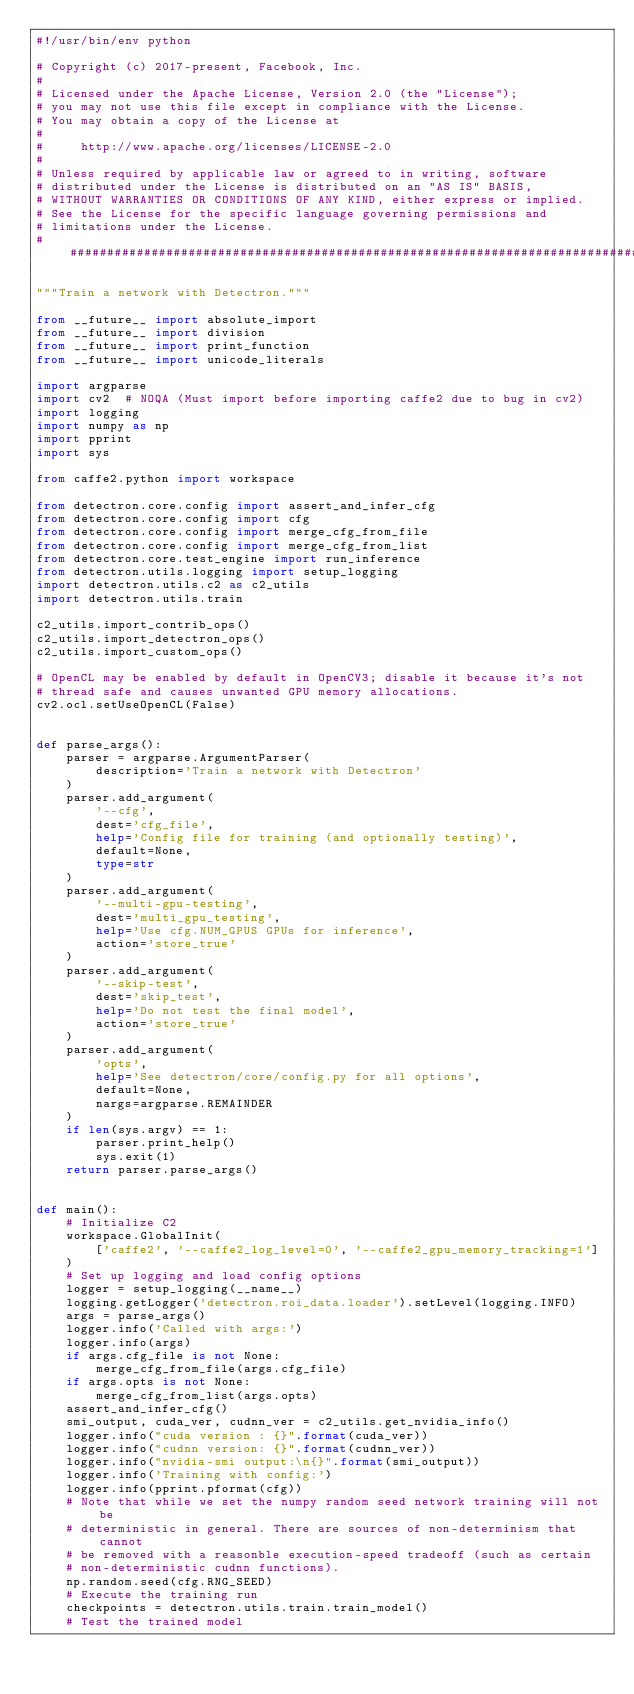Convert code to text. <code><loc_0><loc_0><loc_500><loc_500><_Python_>#!/usr/bin/env python

# Copyright (c) 2017-present, Facebook, Inc.
#
# Licensed under the Apache License, Version 2.0 (the "License");
# you may not use this file except in compliance with the License.
# You may obtain a copy of the License at
#
#     http://www.apache.org/licenses/LICENSE-2.0
#
# Unless required by applicable law or agreed to in writing, software
# distributed under the License is distributed on an "AS IS" BASIS,
# WITHOUT WARRANTIES OR CONDITIONS OF ANY KIND, either express or implied.
# See the License for the specific language governing permissions and
# limitations under the License.
##############################################################################

"""Train a network with Detectron."""

from __future__ import absolute_import
from __future__ import division
from __future__ import print_function
from __future__ import unicode_literals

import argparse
import cv2  # NOQA (Must import before importing caffe2 due to bug in cv2)
import logging
import numpy as np
import pprint
import sys

from caffe2.python import workspace

from detectron.core.config import assert_and_infer_cfg
from detectron.core.config import cfg
from detectron.core.config import merge_cfg_from_file
from detectron.core.config import merge_cfg_from_list
from detectron.core.test_engine import run_inference
from detectron.utils.logging import setup_logging
import detectron.utils.c2 as c2_utils
import detectron.utils.train

c2_utils.import_contrib_ops()
c2_utils.import_detectron_ops()
c2_utils.import_custom_ops()

# OpenCL may be enabled by default in OpenCV3; disable it because it's not
# thread safe and causes unwanted GPU memory allocations.
cv2.ocl.setUseOpenCL(False)


def parse_args():
    parser = argparse.ArgumentParser(
        description='Train a network with Detectron'
    )
    parser.add_argument(
        '--cfg',
        dest='cfg_file',
        help='Config file for training (and optionally testing)',
        default=None,
        type=str
    )
    parser.add_argument(
        '--multi-gpu-testing',
        dest='multi_gpu_testing',
        help='Use cfg.NUM_GPUS GPUs for inference',
        action='store_true'
    )
    parser.add_argument(
        '--skip-test',
        dest='skip_test',
        help='Do not test the final model',
        action='store_true'
    )
    parser.add_argument(
        'opts',
        help='See detectron/core/config.py for all options',
        default=None,
        nargs=argparse.REMAINDER
    )
    if len(sys.argv) == 1:
        parser.print_help()
        sys.exit(1)
    return parser.parse_args()


def main():
    # Initialize C2
    workspace.GlobalInit(
        ['caffe2', '--caffe2_log_level=0', '--caffe2_gpu_memory_tracking=1']
    )
    # Set up logging and load config options
    logger = setup_logging(__name__)
    logging.getLogger('detectron.roi_data.loader').setLevel(logging.INFO)
    args = parse_args()
    logger.info('Called with args:')
    logger.info(args)
    if args.cfg_file is not None:
        merge_cfg_from_file(args.cfg_file)
    if args.opts is not None:
        merge_cfg_from_list(args.opts)
    assert_and_infer_cfg()
    smi_output, cuda_ver, cudnn_ver = c2_utils.get_nvidia_info()
    logger.info("cuda version : {}".format(cuda_ver))
    logger.info("cudnn version: {}".format(cudnn_ver))
    logger.info("nvidia-smi output:\n{}".format(smi_output))
    logger.info('Training with config:')
    logger.info(pprint.pformat(cfg))
    # Note that while we set the numpy random seed network training will not be
    # deterministic in general. There are sources of non-determinism that cannot
    # be removed with a reasonble execution-speed tradeoff (such as certain
    # non-deterministic cudnn functions).
    np.random.seed(cfg.RNG_SEED)
    # Execute the training run
    checkpoints = detectron.utils.train.train_model()
    # Test the trained model</code> 